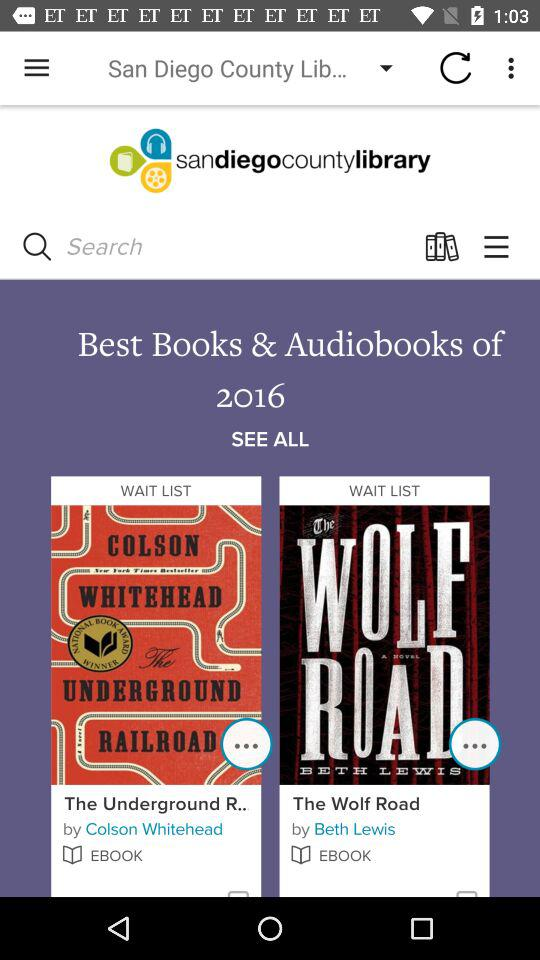What is the name of the author of the ebook "The Wolf Road"? The name of the author is Beth Lewis. 